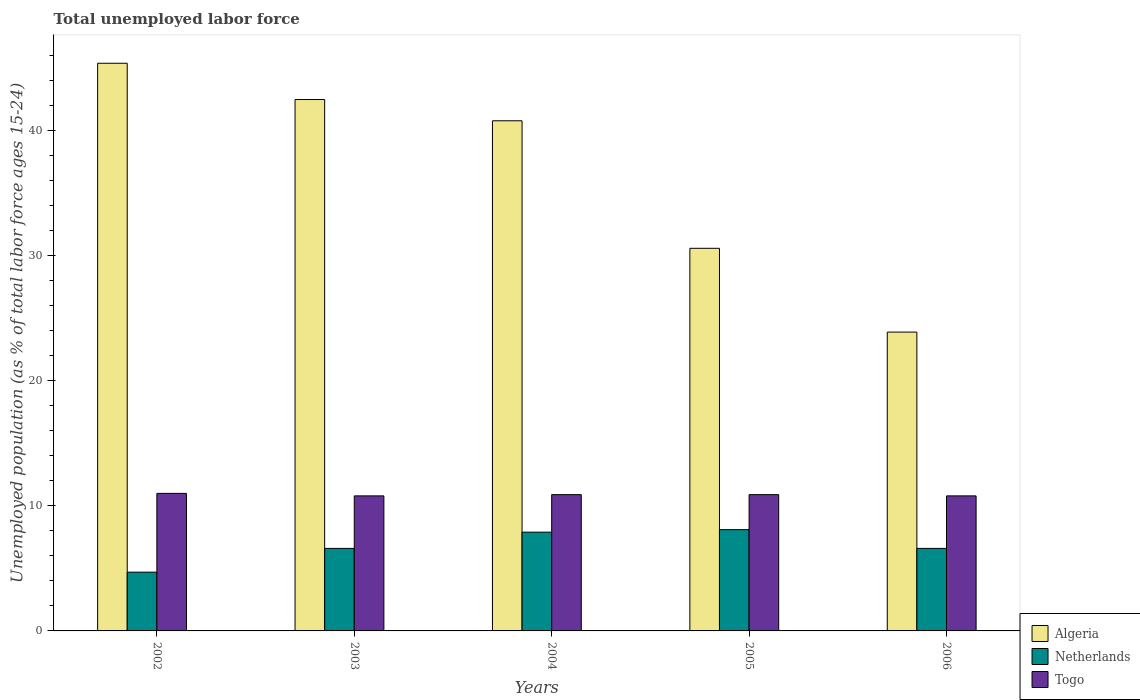How many different coloured bars are there?
Keep it short and to the point. 3. Are the number of bars per tick equal to the number of legend labels?
Your response must be concise. Yes. How many bars are there on the 2nd tick from the left?
Offer a very short reply. 3. What is the label of the 3rd group of bars from the left?
Provide a short and direct response. 2004. In how many cases, is the number of bars for a given year not equal to the number of legend labels?
Your answer should be very brief. 0. What is the percentage of unemployed population in in Netherlands in 2005?
Your answer should be very brief. 8.1. Across all years, what is the maximum percentage of unemployed population in in Netherlands?
Your answer should be very brief. 8.1. Across all years, what is the minimum percentage of unemployed population in in Netherlands?
Offer a very short reply. 4.7. What is the total percentage of unemployed population in in Netherlands in the graph?
Provide a short and direct response. 33.9. What is the difference between the percentage of unemployed population in in Togo in 2002 and that in 2005?
Ensure brevity in your answer.  0.1. What is the difference between the percentage of unemployed population in in Algeria in 2005 and the percentage of unemployed population in in Togo in 2002?
Give a very brief answer. 19.6. What is the average percentage of unemployed population in in Togo per year?
Your answer should be very brief. 10.88. In the year 2002, what is the difference between the percentage of unemployed population in in Algeria and percentage of unemployed population in in Togo?
Your answer should be compact. 34.4. What is the ratio of the percentage of unemployed population in in Netherlands in 2004 to that in 2005?
Your response must be concise. 0.98. Is the difference between the percentage of unemployed population in in Algeria in 2003 and 2004 greater than the difference between the percentage of unemployed population in in Togo in 2003 and 2004?
Give a very brief answer. Yes. What is the difference between the highest and the second highest percentage of unemployed population in in Togo?
Your answer should be very brief. 0.1. What is the difference between the highest and the lowest percentage of unemployed population in in Togo?
Keep it short and to the point. 0.2. What does the 1st bar from the left in 2004 represents?
Provide a succinct answer. Algeria. What does the 3rd bar from the right in 2002 represents?
Give a very brief answer. Algeria. What is the difference between two consecutive major ticks on the Y-axis?
Make the answer very short. 10. Does the graph contain any zero values?
Your response must be concise. No. What is the title of the graph?
Give a very brief answer. Total unemployed labor force. What is the label or title of the X-axis?
Provide a short and direct response. Years. What is the label or title of the Y-axis?
Your answer should be very brief. Unemployed population (as % of total labor force ages 15-24). What is the Unemployed population (as % of total labor force ages 15-24) in Algeria in 2002?
Provide a succinct answer. 45.4. What is the Unemployed population (as % of total labor force ages 15-24) of Netherlands in 2002?
Keep it short and to the point. 4.7. What is the Unemployed population (as % of total labor force ages 15-24) in Togo in 2002?
Offer a terse response. 11. What is the Unemployed population (as % of total labor force ages 15-24) of Algeria in 2003?
Your answer should be compact. 42.5. What is the Unemployed population (as % of total labor force ages 15-24) in Netherlands in 2003?
Offer a very short reply. 6.6. What is the Unemployed population (as % of total labor force ages 15-24) of Togo in 2003?
Your response must be concise. 10.8. What is the Unemployed population (as % of total labor force ages 15-24) in Algeria in 2004?
Give a very brief answer. 40.8. What is the Unemployed population (as % of total labor force ages 15-24) of Netherlands in 2004?
Provide a succinct answer. 7.9. What is the Unemployed population (as % of total labor force ages 15-24) of Togo in 2004?
Keep it short and to the point. 10.9. What is the Unemployed population (as % of total labor force ages 15-24) in Algeria in 2005?
Provide a short and direct response. 30.6. What is the Unemployed population (as % of total labor force ages 15-24) in Netherlands in 2005?
Your response must be concise. 8.1. What is the Unemployed population (as % of total labor force ages 15-24) of Togo in 2005?
Ensure brevity in your answer.  10.9. What is the Unemployed population (as % of total labor force ages 15-24) in Algeria in 2006?
Provide a short and direct response. 23.9. What is the Unemployed population (as % of total labor force ages 15-24) in Netherlands in 2006?
Your response must be concise. 6.6. What is the Unemployed population (as % of total labor force ages 15-24) in Togo in 2006?
Keep it short and to the point. 10.8. Across all years, what is the maximum Unemployed population (as % of total labor force ages 15-24) in Algeria?
Give a very brief answer. 45.4. Across all years, what is the maximum Unemployed population (as % of total labor force ages 15-24) of Netherlands?
Offer a very short reply. 8.1. Across all years, what is the minimum Unemployed population (as % of total labor force ages 15-24) of Algeria?
Your answer should be very brief. 23.9. Across all years, what is the minimum Unemployed population (as % of total labor force ages 15-24) in Netherlands?
Your response must be concise. 4.7. Across all years, what is the minimum Unemployed population (as % of total labor force ages 15-24) of Togo?
Offer a very short reply. 10.8. What is the total Unemployed population (as % of total labor force ages 15-24) in Algeria in the graph?
Offer a terse response. 183.2. What is the total Unemployed population (as % of total labor force ages 15-24) in Netherlands in the graph?
Ensure brevity in your answer.  33.9. What is the total Unemployed population (as % of total labor force ages 15-24) in Togo in the graph?
Offer a terse response. 54.4. What is the difference between the Unemployed population (as % of total labor force ages 15-24) of Algeria in 2002 and that in 2004?
Keep it short and to the point. 4.6. What is the difference between the Unemployed population (as % of total labor force ages 15-24) of Netherlands in 2002 and that in 2004?
Your answer should be compact. -3.2. What is the difference between the Unemployed population (as % of total labor force ages 15-24) in Togo in 2002 and that in 2004?
Keep it short and to the point. 0.1. What is the difference between the Unemployed population (as % of total labor force ages 15-24) of Togo in 2002 and that in 2005?
Keep it short and to the point. 0.1. What is the difference between the Unemployed population (as % of total labor force ages 15-24) of Algeria in 2002 and that in 2006?
Your answer should be very brief. 21.5. What is the difference between the Unemployed population (as % of total labor force ages 15-24) in Netherlands in 2002 and that in 2006?
Make the answer very short. -1.9. What is the difference between the Unemployed population (as % of total labor force ages 15-24) in Algeria in 2003 and that in 2004?
Your answer should be very brief. 1.7. What is the difference between the Unemployed population (as % of total labor force ages 15-24) of Algeria in 2003 and that in 2005?
Your answer should be very brief. 11.9. What is the difference between the Unemployed population (as % of total labor force ages 15-24) of Netherlands in 2003 and that in 2005?
Make the answer very short. -1.5. What is the difference between the Unemployed population (as % of total labor force ages 15-24) in Togo in 2003 and that in 2005?
Offer a terse response. -0.1. What is the difference between the Unemployed population (as % of total labor force ages 15-24) of Netherlands in 2003 and that in 2006?
Your response must be concise. 0. What is the difference between the Unemployed population (as % of total labor force ages 15-24) in Algeria in 2004 and that in 2005?
Your answer should be very brief. 10.2. What is the difference between the Unemployed population (as % of total labor force ages 15-24) in Netherlands in 2004 and that in 2005?
Offer a very short reply. -0.2. What is the difference between the Unemployed population (as % of total labor force ages 15-24) in Algeria in 2004 and that in 2006?
Offer a very short reply. 16.9. What is the difference between the Unemployed population (as % of total labor force ages 15-24) in Netherlands in 2005 and that in 2006?
Provide a short and direct response. 1.5. What is the difference between the Unemployed population (as % of total labor force ages 15-24) of Algeria in 2002 and the Unemployed population (as % of total labor force ages 15-24) of Netherlands in 2003?
Provide a short and direct response. 38.8. What is the difference between the Unemployed population (as % of total labor force ages 15-24) in Algeria in 2002 and the Unemployed population (as % of total labor force ages 15-24) in Togo in 2003?
Your response must be concise. 34.6. What is the difference between the Unemployed population (as % of total labor force ages 15-24) of Netherlands in 2002 and the Unemployed population (as % of total labor force ages 15-24) of Togo in 2003?
Ensure brevity in your answer.  -6.1. What is the difference between the Unemployed population (as % of total labor force ages 15-24) in Algeria in 2002 and the Unemployed population (as % of total labor force ages 15-24) in Netherlands in 2004?
Keep it short and to the point. 37.5. What is the difference between the Unemployed population (as % of total labor force ages 15-24) of Algeria in 2002 and the Unemployed population (as % of total labor force ages 15-24) of Togo in 2004?
Provide a succinct answer. 34.5. What is the difference between the Unemployed population (as % of total labor force ages 15-24) of Netherlands in 2002 and the Unemployed population (as % of total labor force ages 15-24) of Togo in 2004?
Offer a very short reply. -6.2. What is the difference between the Unemployed population (as % of total labor force ages 15-24) in Algeria in 2002 and the Unemployed population (as % of total labor force ages 15-24) in Netherlands in 2005?
Ensure brevity in your answer.  37.3. What is the difference between the Unemployed population (as % of total labor force ages 15-24) of Algeria in 2002 and the Unemployed population (as % of total labor force ages 15-24) of Togo in 2005?
Provide a succinct answer. 34.5. What is the difference between the Unemployed population (as % of total labor force ages 15-24) in Netherlands in 2002 and the Unemployed population (as % of total labor force ages 15-24) in Togo in 2005?
Your response must be concise. -6.2. What is the difference between the Unemployed population (as % of total labor force ages 15-24) of Algeria in 2002 and the Unemployed population (as % of total labor force ages 15-24) of Netherlands in 2006?
Your answer should be compact. 38.8. What is the difference between the Unemployed population (as % of total labor force ages 15-24) of Algeria in 2002 and the Unemployed population (as % of total labor force ages 15-24) of Togo in 2006?
Offer a very short reply. 34.6. What is the difference between the Unemployed population (as % of total labor force ages 15-24) in Netherlands in 2002 and the Unemployed population (as % of total labor force ages 15-24) in Togo in 2006?
Give a very brief answer. -6.1. What is the difference between the Unemployed population (as % of total labor force ages 15-24) in Algeria in 2003 and the Unemployed population (as % of total labor force ages 15-24) in Netherlands in 2004?
Keep it short and to the point. 34.6. What is the difference between the Unemployed population (as % of total labor force ages 15-24) in Algeria in 2003 and the Unemployed population (as % of total labor force ages 15-24) in Togo in 2004?
Ensure brevity in your answer.  31.6. What is the difference between the Unemployed population (as % of total labor force ages 15-24) in Algeria in 2003 and the Unemployed population (as % of total labor force ages 15-24) in Netherlands in 2005?
Your answer should be very brief. 34.4. What is the difference between the Unemployed population (as % of total labor force ages 15-24) of Algeria in 2003 and the Unemployed population (as % of total labor force ages 15-24) of Togo in 2005?
Make the answer very short. 31.6. What is the difference between the Unemployed population (as % of total labor force ages 15-24) in Algeria in 2003 and the Unemployed population (as % of total labor force ages 15-24) in Netherlands in 2006?
Provide a succinct answer. 35.9. What is the difference between the Unemployed population (as % of total labor force ages 15-24) of Algeria in 2003 and the Unemployed population (as % of total labor force ages 15-24) of Togo in 2006?
Your answer should be very brief. 31.7. What is the difference between the Unemployed population (as % of total labor force ages 15-24) in Netherlands in 2003 and the Unemployed population (as % of total labor force ages 15-24) in Togo in 2006?
Your answer should be compact. -4.2. What is the difference between the Unemployed population (as % of total labor force ages 15-24) of Algeria in 2004 and the Unemployed population (as % of total labor force ages 15-24) of Netherlands in 2005?
Make the answer very short. 32.7. What is the difference between the Unemployed population (as % of total labor force ages 15-24) in Algeria in 2004 and the Unemployed population (as % of total labor force ages 15-24) in Togo in 2005?
Offer a terse response. 29.9. What is the difference between the Unemployed population (as % of total labor force ages 15-24) in Netherlands in 2004 and the Unemployed population (as % of total labor force ages 15-24) in Togo in 2005?
Give a very brief answer. -3. What is the difference between the Unemployed population (as % of total labor force ages 15-24) of Algeria in 2004 and the Unemployed population (as % of total labor force ages 15-24) of Netherlands in 2006?
Give a very brief answer. 34.2. What is the difference between the Unemployed population (as % of total labor force ages 15-24) of Algeria in 2005 and the Unemployed population (as % of total labor force ages 15-24) of Netherlands in 2006?
Provide a succinct answer. 24. What is the difference between the Unemployed population (as % of total labor force ages 15-24) of Algeria in 2005 and the Unemployed population (as % of total labor force ages 15-24) of Togo in 2006?
Give a very brief answer. 19.8. What is the difference between the Unemployed population (as % of total labor force ages 15-24) in Netherlands in 2005 and the Unemployed population (as % of total labor force ages 15-24) in Togo in 2006?
Offer a very short reply. -2.7. What is the average Unemployed population (as % of total labor force ages 15-24) in Algeria per year?
Give a very brief answer. 36.64. What is the average Unemployed population (as % of total labor force ages 15-24) in Netherlands per year?
Your answer should be compact. 6.78. What is the average Unemployed population (as % of total labor force ages 15-24) of Togo per year?
Your answer should be compact. 10.88. In the year 2002, what is the difference between the Unemployed population (as % of total labor force ages 15-24) of Algeria and Unemployed population (as % of total labor force ages 15-24) of Netherlands?
Ensure brevity in your answer.  40.7. In the year 2002, what is the difference between the Unemployed population (as % of total labor force ages 15-24) in Algeria and Unemployed population (as % of total labor force ages 15-24) in Togo?
Provide a short and direct response. 34.4. In the year 2002, what is the difference between the Unemployed population (as % of total labor force ages 15-24) of Netherlands and Unemployed population (as % of total labor force ages 15-24) of Togo?
Ensure brevity in your answer.  -6.3. In the year 2003, what is the difference between the Unemployed population (as % of total labor force ages 15-24) of Algeria and Unemployed population (as % of total labor force ages 15-24) of Netherlands?
Provide a short and direct response. 35.9. In the year 2003, what is the difference between the Unemployed population (as % of total labor force ages 15-24) of Algeria and Unemployed population (as % of total labor force ages 15-24) of Togo?
Your answer should be very brief. 31.7. In the year 2004, what is the difference between the Unemployed population (as % of total labor force ages 15-24) of Algeria and Unemployed population (as % of total labor force ages 15-24) of Netherlands?
Make the answer very short. 32.9. In the year 2004, what is the difference between the Unemployed population (as % of total labor force ages 15-24) of Algeria and Unemployed population (as % of total labor force ages 15-24) of Togo?
Keep it short and to the point. 29.9. In the year 2004, what is the difference between the Unemployed population (as % of total labor force ages 15-24) of Netherlands and Unemployed population (as % of total labor force ages 15-24) of Togo?
Ensure brevity in your answer.  -3. In the year 2005, what is the difference between the Unemployed population (as % of total labor force ages 15-24) of Algeria and Unemployed population (as % of total labor force ages 15-24) of Togo?
Offer a very short reply. 19.7. In the year 2005, what is the difference between the Unemployed population (as % of total labor force ages 15-24) of Netherlands and Unemployed population (as % of total labor force ages 15-24) of Togo?
Ensure brevity in your answer.  -2.8. In the year 2006, what is the difference between the Unemployed population (as % of total labor force ages 15-24) in Algeria and Unemployed population (as % of total labor force ages 15-24) in Netherlands?
Provide a short and direct response. 17.3. In the year 2006, what is the difference between the Unemployed population (as % of total labor force ages 15-24) of Netherlands and Unemployed population (as % of total labor force ages 15-24) of Togo?
Your answer should be very brief. -4.2. What is the ratio of the Unemployed population (as % of total labor force ages 15-24) in Algeria in 2002 to that in 2003?
Give a very brief answer. 1.07. What is the ratio of the Unemployed population (as % of total labor force ages 15-24) of Netherlands in 2002 to that in 2003?
Keep it short and to the point. 0.71. What is the ratio of the Unemployed population (as % of total labor force ages 15-24) of Togo in 2002 to that in 2003?
Your response must be concise. 1.02. What is the ratio of the Unemployed population (as % of total labor force ages 15-24) of Algeria in 2002 to that in 2004?
Your answer should be very brief. 1.11. What is the ratio of the Unemployed population (as % of total labor force ages 15-24) of Netherlands in 2002 to that in 2004?
Your answer should be compact. 0.59. What is the ratio of the Unemployed population (as % of total labor force ages 15-24) in Togo in 2002 to that in 2004?
Your answer should be very brief. 1.01. What is the ratio of the Unemployed population (as % of total labor force ages 15-24) in Algeria in 2002 to that in 2005?
Keep it short and to the point. 1.48. What is the ratio of the Unemployed population (as % of total labor force ages 15-24) of Netherlands in 2002 to that in 2005?
Offer a terse response. 0.58. What is the ratio of the Unemployed population (as % of total labor force ages 15-24) in Togo in 2002 to that in 2005?
Offer a very short reply. 1.01. What is the ratio of the Unemployed population (as % of total labor force ages 15-24) of Algeria in 2002 to that in 2006?
Provide a short and direct response. 1.9. What is the ratio of the Unemployed population (as % of total labor force ages 15-24) of Netherlands in 2002 to that in 2006?
Provide a succinct answer. 0.71. What is the ratio of the Unemployed population (as % of total labor force ages 15-24) of Togo in 2002 to that in 2006?
Ensure brevity in your answer.  1.02. What is the ratio of the Unemployed population (as % of total labor force ages 15-24) in Algeria in 2003 to that in 2004?
Provide a succinct answer. 1.04. What is the ratio of the Unemployed population (as % of total labor force ages 15-24) of Netherlands in 2003 to that in 2004?
Offer a terse response. 0.84. What is the ratio of the Unemployed population (as % of total labor force ages 15-24) of Togo in 2003 to that in 2004?
Your answer should be very brief. 0.99. What is the ratio of the Unemployed population (as % of total labor force ages 15-24) of Algeria in 2003 to that in 2005?
Your response must be concise. 1.39. What is the ratio of the Unemployed population (as % of total labor force ages 15-24) of Netherlands in 2003 to that in 2005?
Offer a very short reply. 0.81. What is the ratio of the Unemployed population (as % of total labor force ages 15-24) of Togo in 2003 to that in 2005?
Make the answer very short. 0.99. What is the ratio of the Unemployed population (as % of total labor force ages 15-24) of Algeria in 2003 to that in 2006?
Offer a very short reply. 1.78. What is the ratio of the Unemployed population (as % of total labor force ages 15-24) in Netherlands in 2003 to that in 2006?
Give a very brief answer. 1. What is the ratio of the Unemployed population (as % of total labor force ages 15-24) of Togo in 2003 to that in 2006?
Keep it short and to the point. 1. What is the ratio of the Unemployed population (as % of total labor force ages 15-24) in Netherlands in 2004 to that in 2005?
Offer a very short reply. 0.98. What is the ratio of the Unemployed population (as % of total labor force ages 15-24) of Algeria in 2004 to that in 2006?
Offer a very short reply. 1.71. What is the ratio of the Unemployed population (as % of total labor force ages 15-24) of Netherlands in 2004 to that in 2006?
Provide a short and direct response. 1.2. What is the ratio of the Unemployed population (as % of total labor force ages 15-24) of Togo in 2004 to that in 2006?
Keep it short and to the point. 1.01. What is the ratio of the Unemployed population (as % of total labor force ages 15-24) of Algeria in 2005 to that in 2006?
Your answer should be compact. 1.28. What is the ratio of the Unemployed population (as % of total labor force ages 15-24) of Netherlands in 2005 to that in 2006?
Provide a short and direct response. 1.23. What is the ratio of the Unemployed population (as % of total labor force ages 15-24) of Togo in 2005 to that in 2006?
Provide a succinct answer. 1.01. What is the difference between the highest and the second highest Unemployed population (as % of total labor force ages 15-24) of Algeria?
Provide a short and direct response. 2.9. What is the difference between the highest and the lowest Unemployed population (as % of total labor force ages 15-24) of Netherlands?
Your answer should be very brief. 3.4. 